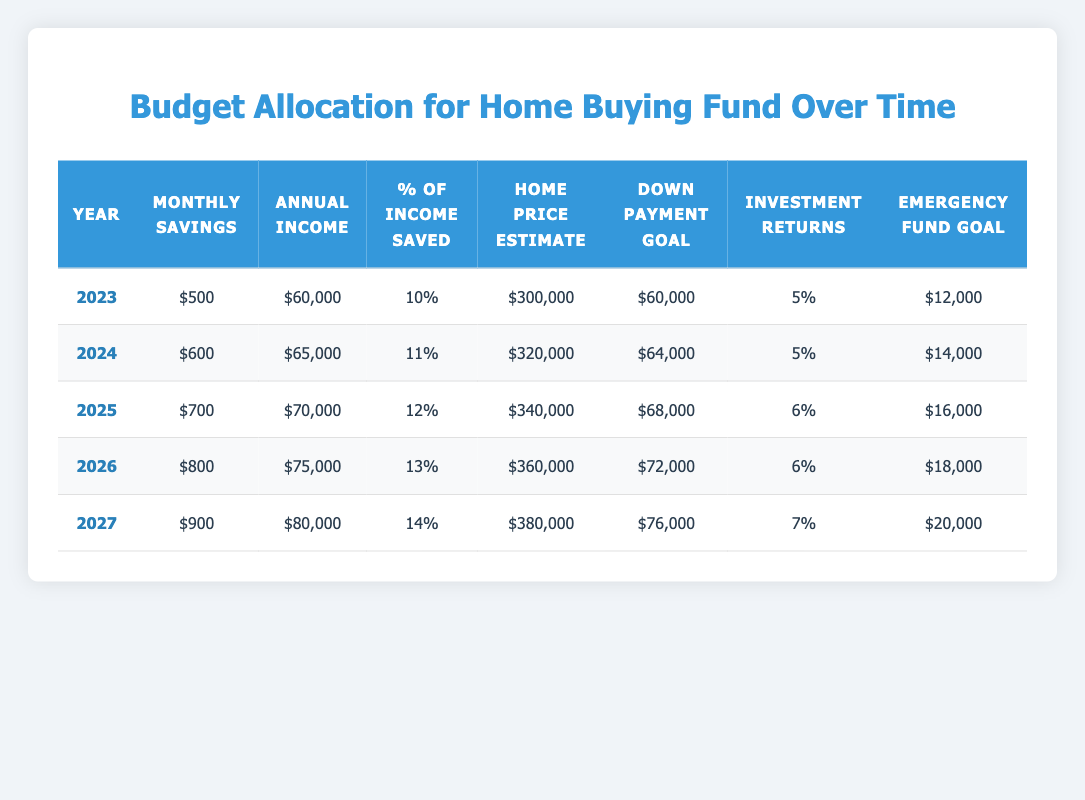What is the monthly savings in 2025? The row for the year 2025 shows "Monthly Savings" as 700.
Answer: 700 In which year does the down payment goal exceed $70,000? By examining the "Down Payment Goal" column, the values are 60,000 (2023), 64,000 (2024), 68,000 (2025), 72,000 (2026), and 76,000 (2027). The first year to exceed 70,000 is 2026.
Answer: 2026 What is the average annual income from 2023 to 2027? To find the average annual income, we sum the annual incomes: (60,000 + 65,000 + 70,000 + 75,000 + 80,000) = 350,000. Since there are 5 years, the average is 350,000 / 5 = 70,000.
Answer: 70,000 Is the percentage of income saved increasing each year? Checking the "% of Income Saved" column: it shows 10 (2023), 11 (2024), 12 (2025), 13 (2026), and 14 (2027), which indicates that it is indeed increasing every year.
Answer: Yes What is the total combined emergency fund goal for 2023 and 2024? The "Emergency Fund Goal" for 2023 is 12,000 and for 2024 is 14,000. Adding them together gives us 12,000 + 14,000 = 26,000.
Answer: 26,000 